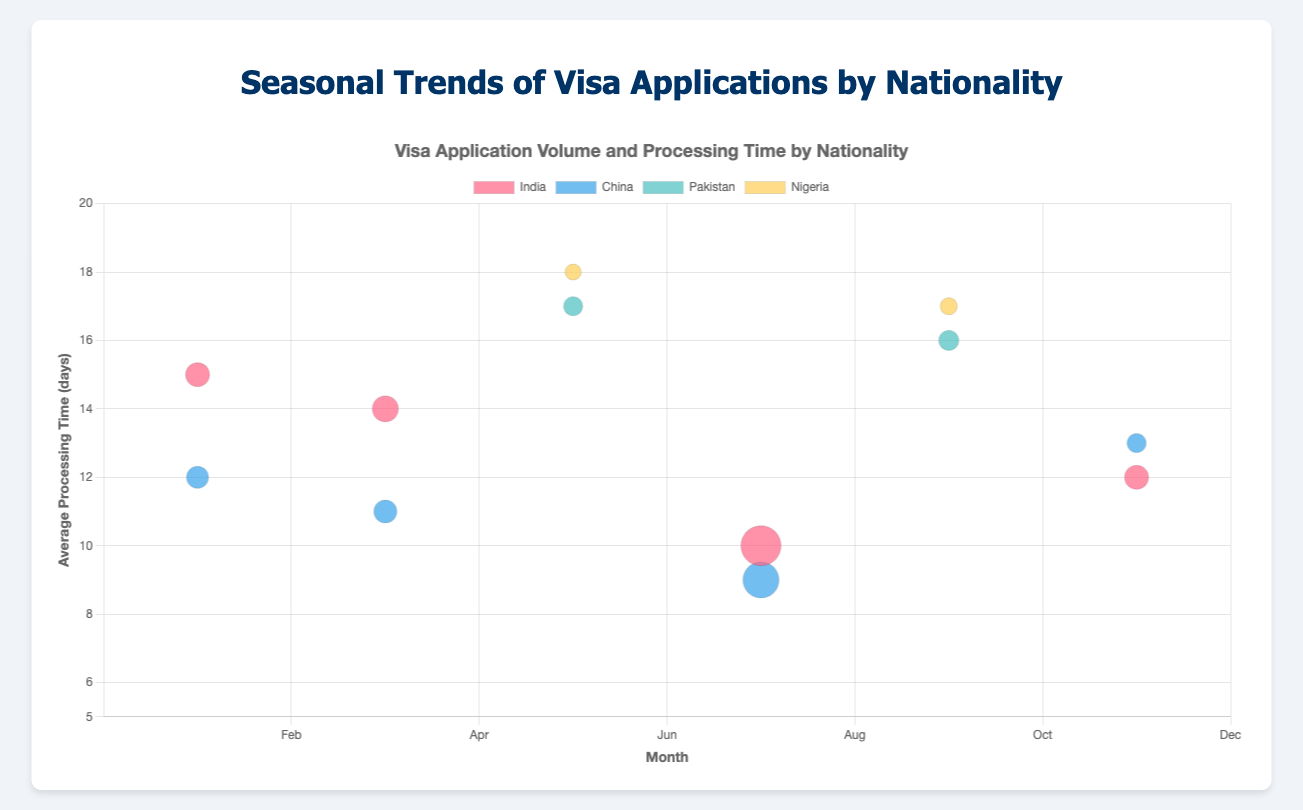What is the title of the chart? The title is usually displayed at the top of the figure. It gives an overview of what the chart represents.
Answer: Seasonal Trends of Visa Applications by Nationality Which nationality has the highest application volume in July? To find this, look at the bubble sizes in the month of July. The largest bubble indicates the highest application volume. The red bubble representing India is the largest in July.
Answer: India Which month had the highest average processing time for Nigerian visa applications? To determine this, examine the y-axis values for data points corresponding to Nigeria, which are represented by yellow bubbles. In May and September, the processing times are 18 and 17 days respectively, with May being the highest.
Answer: May How many data points are there for Chinese visa applications? Count the number of data points specifically colored blue and check if they are labeled for China. This amounts to four data points.
Answer: 4 What is the average processing time for Indian visa applications in March? Look for the red bubble corresponding to India in the month of March, then check the y-axis value, which is 14 days.
Answer: 14 days How does the average processing time for Chinese applications compare between January and July? Identify the blue bubbles for China in January and July. The y-axis values indicate 12 days in January and 9 days in July. Comparing these, it is lower in July.
Answer: Lower in July Which nationality has the smallest application volume in May? Compare the sizes of the bubbles in May. The smallest bubble represents the lowest application volume. The yellow bubble for Nigeria is the smallest.
Answer: Nigeria Which nationality experienced a decrease in the average processing time from March to July? Compare the y-axis values of bubbles for each nationality between March and July. For India, the values change from 14 days in March to 10 days in July, indicating a decrease.
Answer: India What is the trend for Pakistani visa applications from May to September in terms of application volume? Look at the size of the green bubbles for Pakistan in May and September. Both are relatively unchanged, indicating a constant application volume of around 950 to 1000 applications.
Answer: Constant Is there any nationality for which the average processing time remains unchanged between two different months? Compare the y-axis values of bubbles within each nationality. Nigerian visa applications have an almost constant processing time between May and September, both around 17-18 days.
Answer: Nigeria 